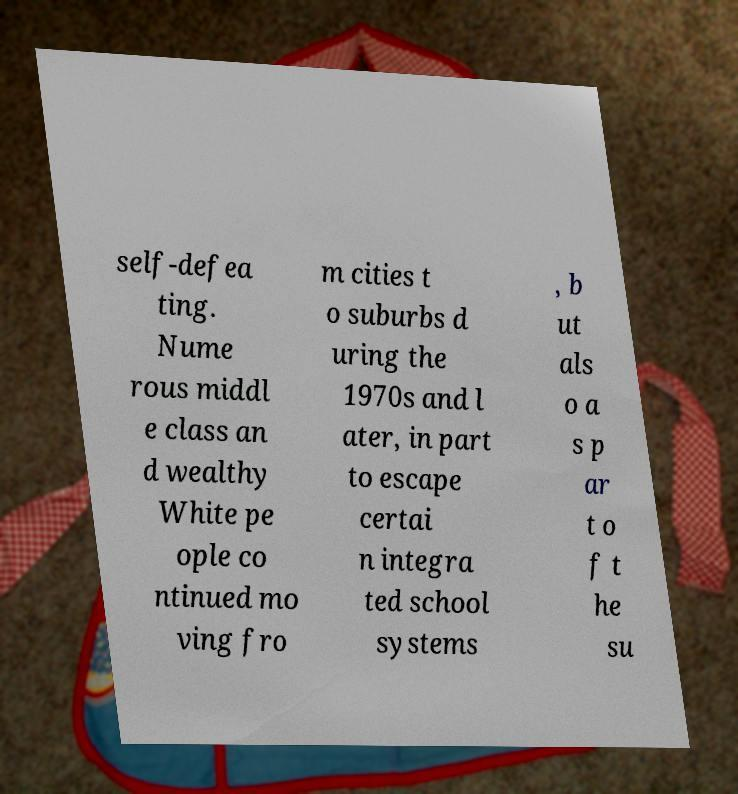What messages or text are displayed in this image? I need them in a readable, typed format. self-defea ting. Nume rous middl e class an d wealthy White pe ople co ntinued mo ving fro m cities t o suburbs d uring the 1970s and l ater, in part to escape certai n integra ted school systems , b ut als o a s p ar t o f t he su 